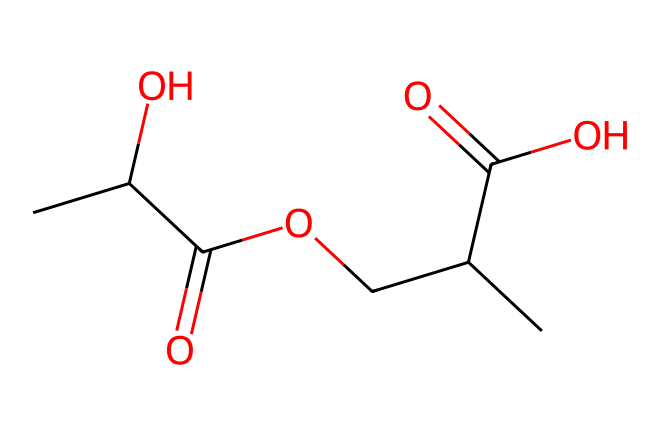How many carbon atoms are in this molecule? The SMILES representation shows "C" for each carbon atom. By counting each 'C' present in the structure, we find there are 8 carbon atoms total.
Answer: 8 What is the main functional group present in this chemical? From the structure, we can identify the presence of carboxylic acid groups (-COOH), which are indicated by the "C(=O)O" part. This makes the functional group a carboxylic acid.
Answer: carboxylic acid How many hydroxyl (–OH) groups are present? The hydroxyl groups can be identified from the "O" attached to a carbon. In this structure, there are two instances of "C(O)", indicating 2 hydroxyl groups.
Answer: 2 What type of chemical bonds are mainly present in this structure? The structure consists of carbon-carbon (C-C) and carbon-oxygen (C-O) bonds. Since there are single and double bonds observed in the SMILES, the main types of bonds here are single bonds and one double bond.
Answer: C-C and C-O What is the overall charge of the molecule? The molecule does not possess any charged atoms or groups; it features neutral functional groups like carboxylic acids and hydroxyls. Thus, the overall charge is zero.
Answer: 0 Can this molecule be considered biodegradable? The presence of ester and carboxylic acid functionalities, along with the natural origin of the components (like fatty acids), suggests it is likely biodegradable.
Answer: likely biodegradable 